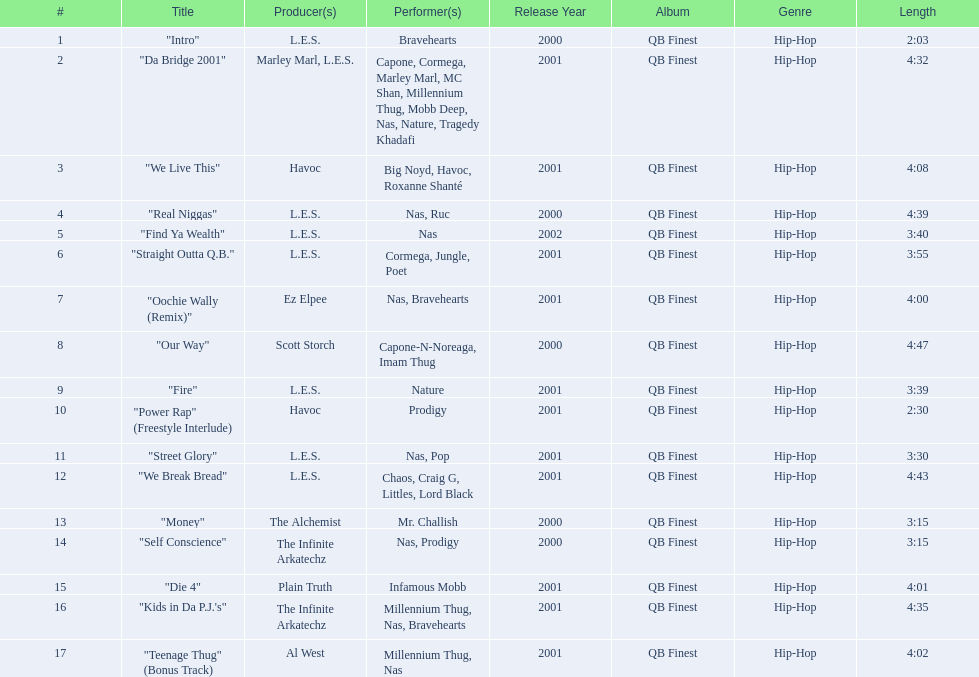Is fire or die 4 longer? "Die 4". 